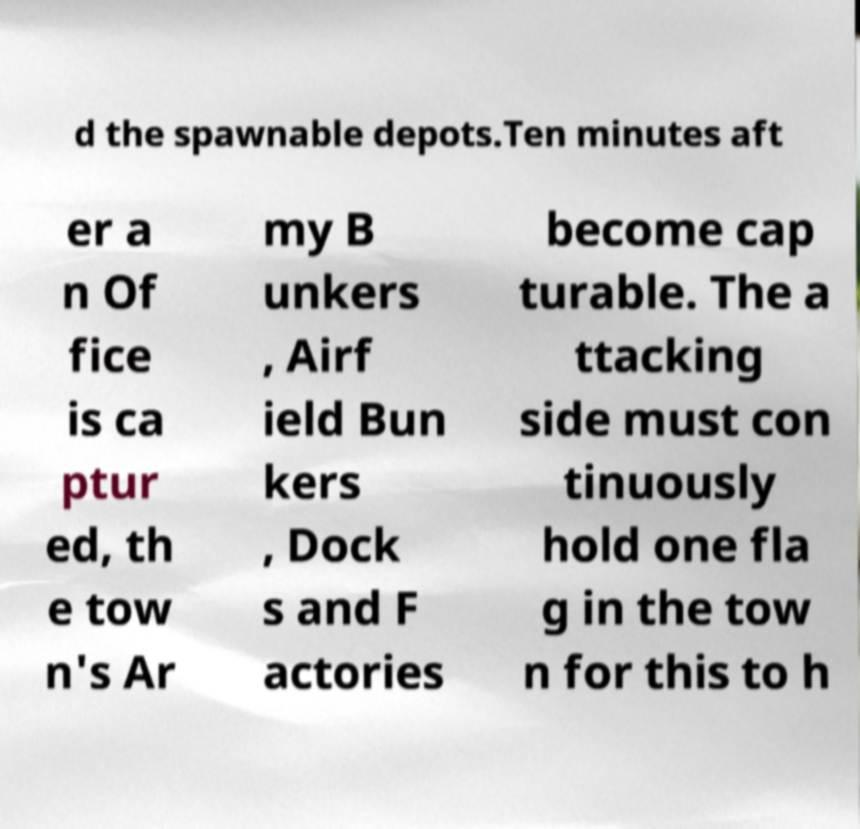There's text embedded in this image that I need extracted. Can you transcribe it verbatim? d the spawnable depots.Ten minutes aft er a n Of fice is ca ptur ed, th e tow n's Ar my B unkers , Airf ield Bun kers , Dock s and F actories become cap turable. The a ttacking side must con tinuously hold one fla g in the tow n for this to h 